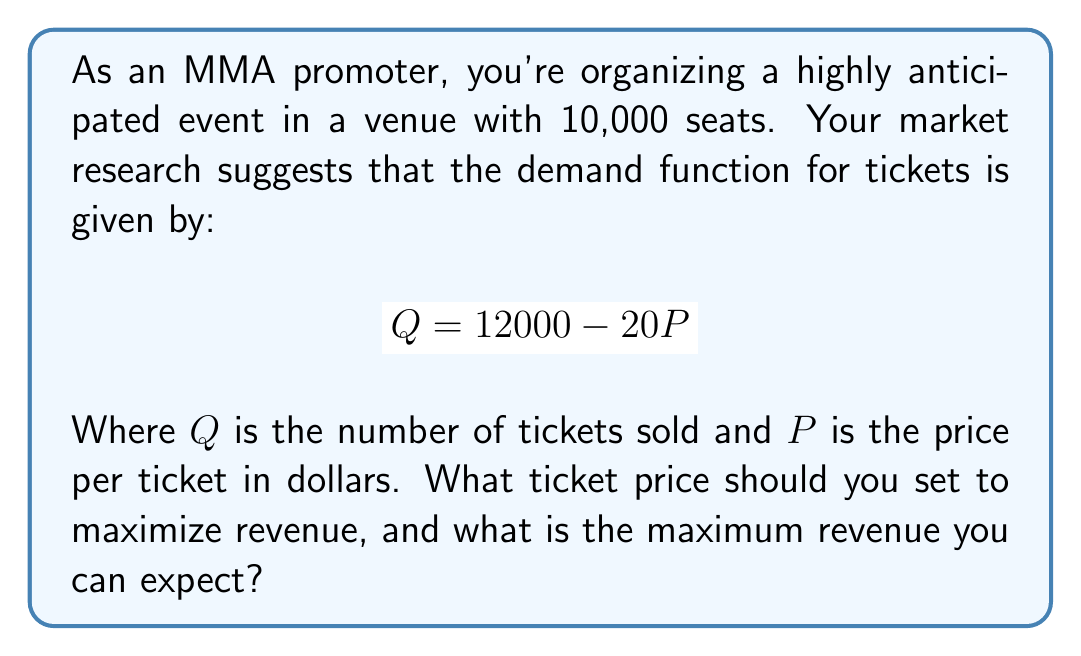Can you answer this question? Let's approach this step-by-step:

1) Revenue (R) is calculated by multiplying price (P) by quantity sold (Q):
   $$R = P \cdot Q$$

2) Substitute the demand function into the revenue equation:
   $$R = P \cdot (12000 - 20P) = 12000P - 20P^2$$

3) To find the maximum revenue, we need to find the price where the derivative of R with respect to P is zero:
   $$\frac{dR}{dP} = 12000 - 40P$$

4) Set this equal to zero and solve for P:
   $$12000 - 40P = 0$$
   $$40P = 12000$$
   $$P = 300$$

5) To confirm this is a maximum (not a minimum), check the second derivative:
   $$\frac{d^2R}{dP^2} = -40$$ (negative, confirming a maximum)

6) Calculate the optimal quantity sold at this price:
   $$Q = 12000 - 20(300) = 6000$$ tickets

7) Calculate the maximum revenue:
   $$R = 300 \cdot 6000 = 1,800,000$$ dollars

Therefore, the optimal ticket price is $300, and the maximum revenue is $1,800,000.
Answer: Optimal price: $300; Maximum revenue: $1,800,000 